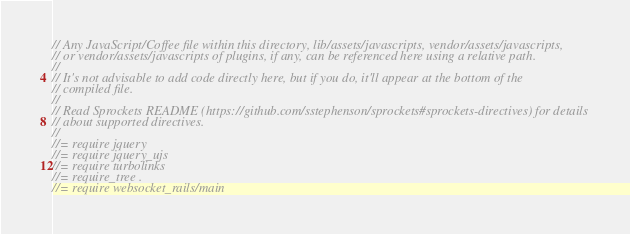Convert code to text. <code><loc_0><loc_0><loc_500><loc_500><_JavaScript_>// Any JavaScript/Coffee file within this directory, lib/assets/javascripts, vendor/assets/javascripts,
// or vendor/assets/javascripts of plugins, if any, can be referenced here using a relative path.
//
// It's not advisable to add code directly here, but if you do, it'll appear at the bottom of the
// compiled file.
//
// Read Sprockets README (https://github.com/sstephenson/sprockets#sprockets-directives) for details
// about supported directives.
//
//= require jquery
//= require jquery_ujs
//= require turbolinks
//= require_tree .
//= require websocket_rails/main

</code> 